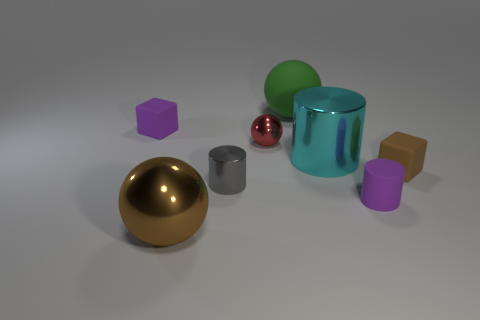There is a matte thing to the left of the green sphere; is it the same size as the small shiny ball?
Keep it short and to the point. Yes. How many other objects are there of the same size as the purple cylinder?
Offer a very short reply. 4. The big matte sphere has what color?
Ensure brevity in your answer.  Green. There is a tiny gray cylinder to the left of the rubber ball; what is its material?
Give a very brief answer. Metal. Are there the same number of gray metallic cylinders on the right side of the small shiny ball and tiny gray rubber cylinders?
Ensure brevity in your answer.  Yes. Is the shape of the tiny red shiny object the same as the brown matte object?
Offer a terse response. No. Is there anything else that has the same color as the big rubber ball?
Your answer should be compact. No. There is a large object that is both in front of the large green matte object and behind the gray metal cylinder; what is its shape?
Offer a terse response. Cylinder. Are there the same number of small rubber blocks behind the gray cylinder and green spheres that are in front of the green thing?
Provide a short and direct response. No. What number of spheres are tiny red shiny things or brown objects?
Your response must be concise. 2. 